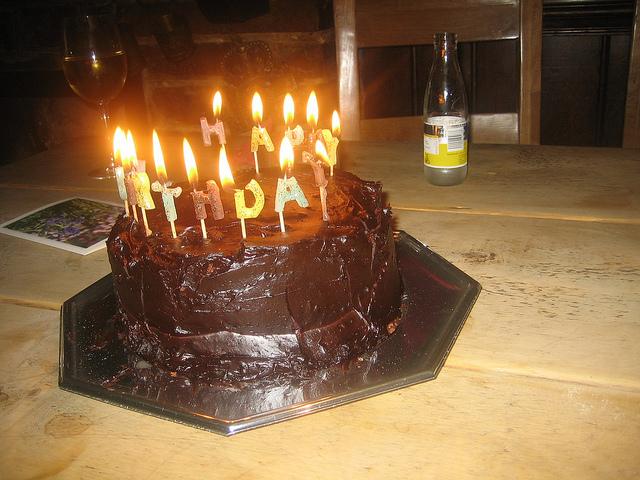What is this celebration for?
Answer briefly. Birthday. Was a beverage served?
Short answer required. Yes. What kind of frosting is on the cake?
Keep it brief. Chocolate. 